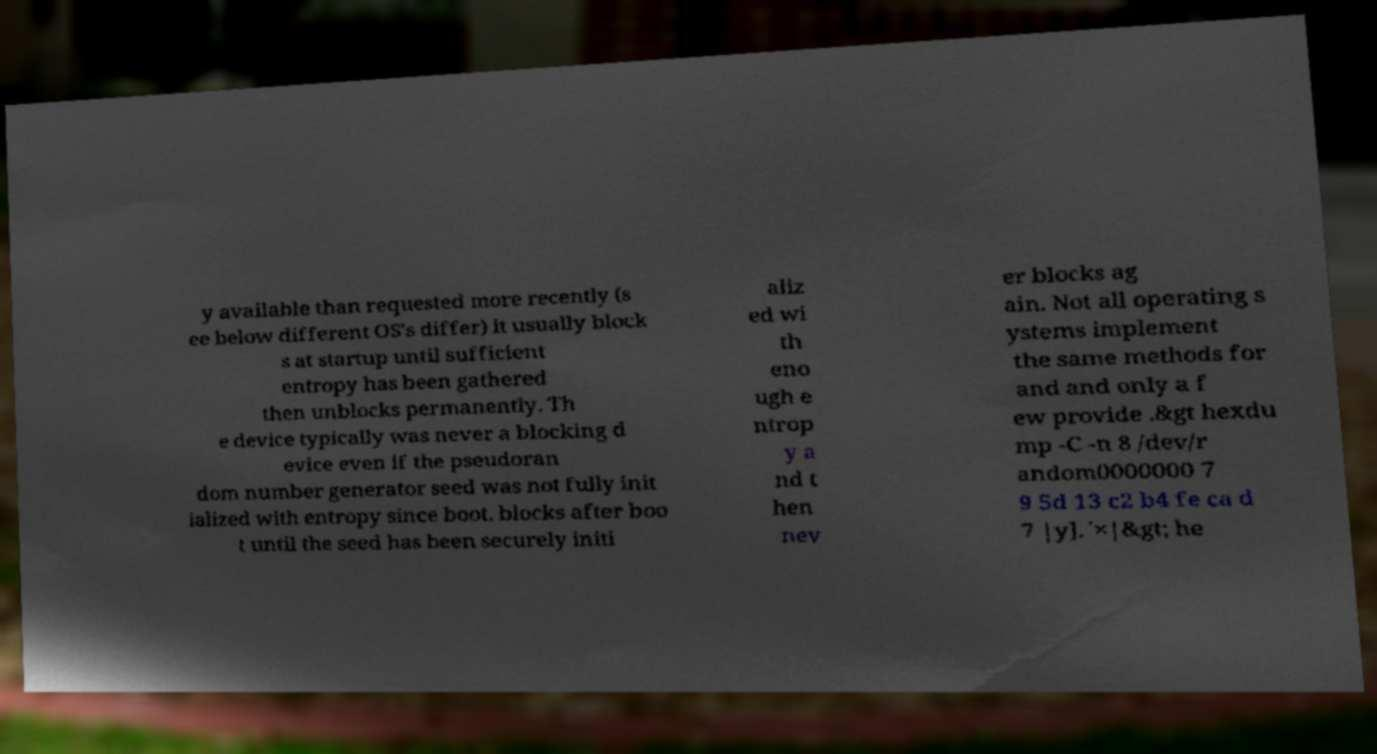Please identify and transcribe the text found in this image. y available than requested more recently (s ee below different OS's differ) it usually block s at startup until sufficient entropy has been gathered then unblocks permanently. Th e device typically was never a blocking d evice even if the pseudoran dom number generator seed was not fully init ialized with entropy since boot. blocks after boo t until the seed has been securely initi aliz ed wi th eno ugh e ntrop y a nd t hen nev er blocks ag ain. Not all operating s ystems implement the same methods for and and only a f ew provide .&gt hexdu mp -C -n 8 /dev/r andom0000000 7 9 5d 13 c2 b4 fe ca d 7 |y].´×|&gt; he 